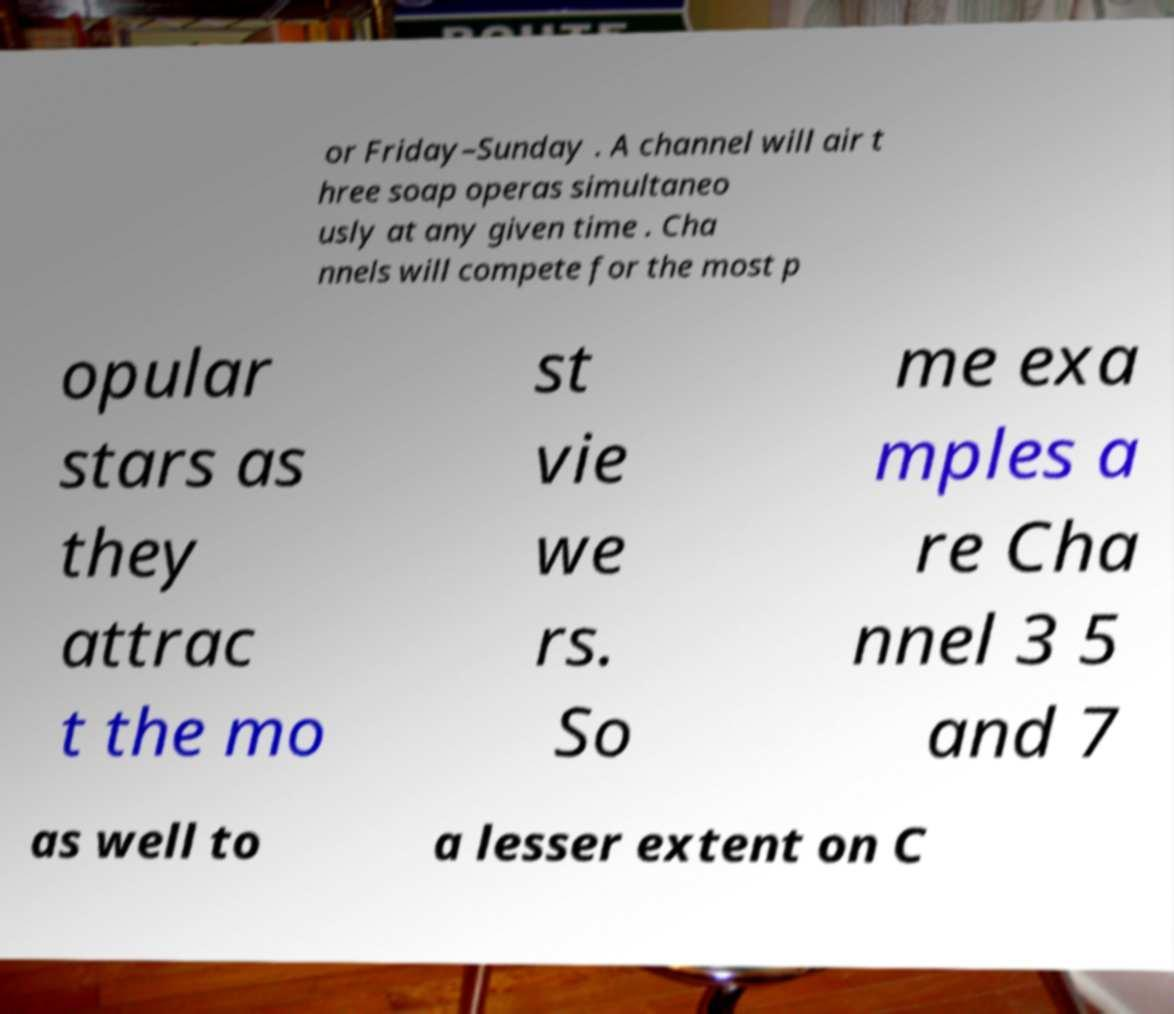For documentation purposes, I need the text within this image transcribed. Could you provide that? or Friday–Sunday . A channel will air t hree soap operas simultaneo usly at any given time . Cha nnels will compete for the most p opular stars as they attrac t the mo st vie we rs. So me exa mples a re Cha nnel 3 5 and 7 as well to a lesser extent on C 